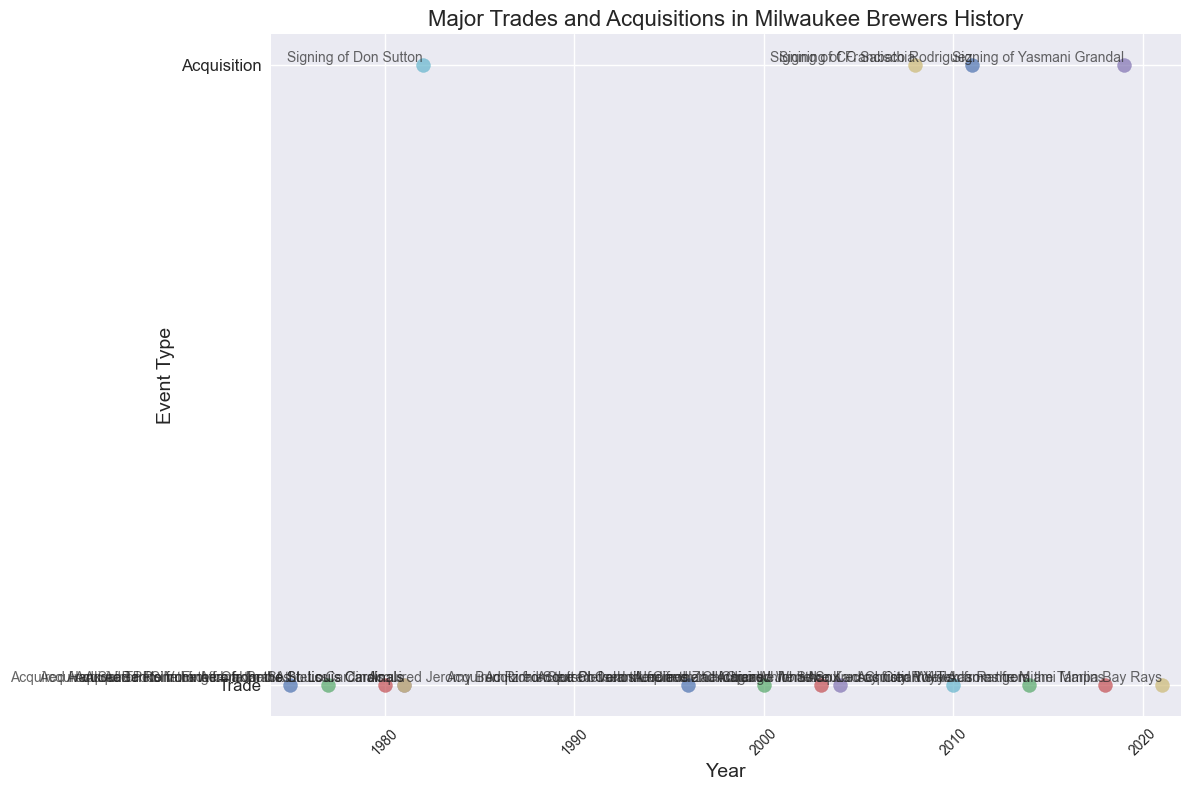When was the earliest major trade or acquisition for the Milwaukee Brewers shown in the plot? According to the plot, the earliest year marked on the x-axis with an event is 1975, indicating the earliest trade or acquisition.
Answer: 1975 Which year had the highest number of acquisitions in Milwaukee Brewers history? By looking at the vertical position of the acquisitions on the y-axis and counting the instances per year, 1981 had multiple acquisitions and is the year with the highest number of acquisitions.
Answer: 1981 How many trades occurred between 2000 and 2020, inclusive? Count all the trades on the plot between the years 2000 and 2020. Trades occurred in the years 2000, 2003, 2004, 2010, 2014, and 2018, totaling 6 trades.
Answer: 6 Who was the latest player acquired via trade as per the plot? The latest year on the x-axis with a "Trade" event is 2021, and the player acquired in this year was Willy Adames from the Tampa Bay Rays.
Answer: Willy Adames How many years after Rollie Fingers was acquired did the Brewers sign Francisco Rodriguez? Rollie Fingers was acquired in 1981, and Francisco Rodriguez was signed in 2011. The difference is 2011 - 1981 = 30 years.
Answer: 30 years Which acquisition happened closest to the trade of Christian Yelich? Christian Yelich was traded in 2018. The closest acquisition was Yasmani Grandal who was signed in 2019, making it just a year’s difference.
Answer: Yasmani Grandal Looking at the plot, which event type (Trade or Acquisition) happened more frequently overall? Comparing the number of markers for "Trade" and "Acquisition" on the plot, trades are more numerous than acquisitions.
Answer: Trade Between the years 1980 and 1990, how many total trades and acquisitions did the Milwaukee Brewers make? Count all the events between 1980 and 1990 from the plot. There are 4 events: Ted Simmons (1980), Rollie Fingers (1981), Pete Vuckovich (1981), and Don Sutton (1982).
Answer: 4 events Who was acquired from the Cleveland Indians, and in which years? According to the plot, Jeromy Burnitz was acquired in 1996, and Richie Sexson was acquired in 2000, both from the Cleveland Indians.
Answer: Jeromy Burnitz (1996), Richie Sexson (2000) What is the median year of all acquisition events on the plot? The acquisition years are 1982, 2008, 2011, and 2019. Listing these in order gives 1982, 2008, 2011, and 2019. The median of these years is the average of 2008 and 2011: (2008 + 2011) / 2 = 2009.5.
Answer: 2009.5 